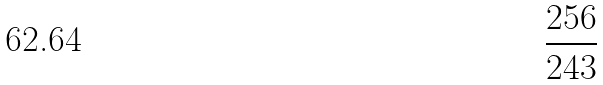<formula> <loc_0><loc_0><loc_500><loc_500>\frac { 2 5 6 } { 2 4 3 }</formula> 